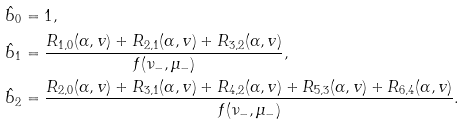Convert formula to latex. <formula><loc_0><loc_0><loc_500><loc_500>\hat { b } _ { 0 } & = 1 , \\ \hat { b } _ { 1 } & = \frac { R _ { 1 , 0 } ( \alpha , v ) + R _ { 2 , 1 } ( \alpha , v ) + R _ { 3 , 2 } ( \alpha , v ) } { f ( \nu _ { - } , \mu _ { - } ) } , \\ \hat { b } _ { 2 } & = \frac { R _ { 2 , 0 } ( \alpha , v ) + R _ { 3 , 1 } ( \alpha , v ) + R _ { 4 , 2 } ( \alpha , v ) + R _ { 5 , 3 } ( \alpha , v ) + R _ { 6 , 4 } ( \alpha , v ) } { f ( \nu _ { - } , \mu _ { - } ) } .</formula> 